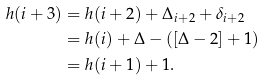Convert formula to latex. <formula><loc_0><loc_0><loc_500><loc_500>h ( i + 3 ) & = h ( i + 2 ) + \Delta _ { i + 2 } + \delta _ { i + 2 } \\ & = h ( i ) + \Delta - ( [ \Delta - 2 ] + 1 ) \\ & = h ( i + 1 ) + 1 .</formula> 